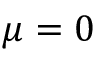Convert formula to latex. <formula><loc_0><loc_0><loc_500><loc_500>\mu = 0</formula> 